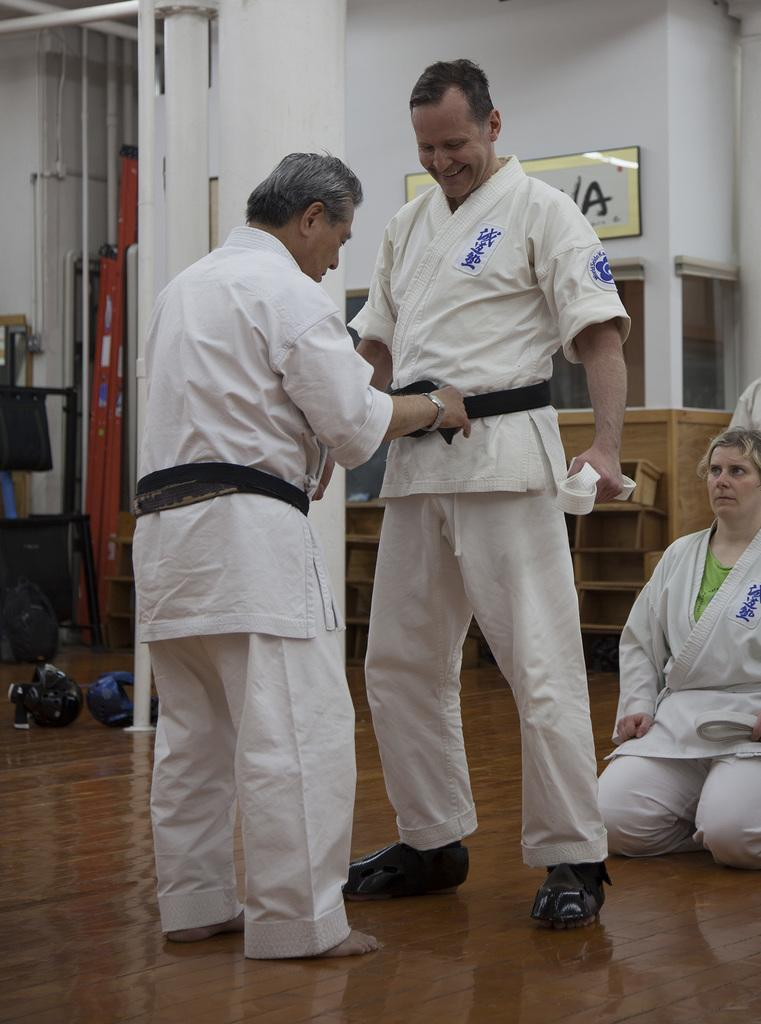<image>
Create a compact narrative representing the image presented. the letter A is on a sign next to the karate people 